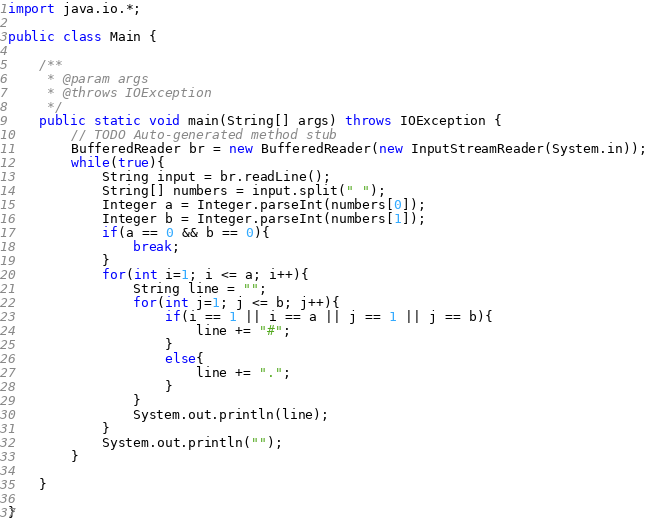<code> <loc_0><loc_0><loc_500><loc_500><_Java_>import java.io.*;

public class Main {

	/**
	 * @param args
	 * @throws IOException 
	 */
	public static void main(String[] args) throws IOException {
		// TODO Auto-generated method stub
		BufferedReader br = new BufferedReader(new InputStreamReader(System.in));
		while(true){
			String input = br.readLine();
			String[] numbers = input.split(" ");
			Integer a = Integer.parseInt(numbers[0]);
			Integer b = Integer.parseInt(numbers[1]);
			if(a == 0 && b == 0){
				break;
			}
			for(int i=1; i <= a; i++){
				String line = "";
				for(int j=1; j <= b; j++){
					if(i == 1 || i == a || j == 1 || j == b){
						line += "#";
					}
					else{
						line += ".";
					}
				}
				System.out.println(line);
			}
			System.out.println("");
		}

	}

}</code> 